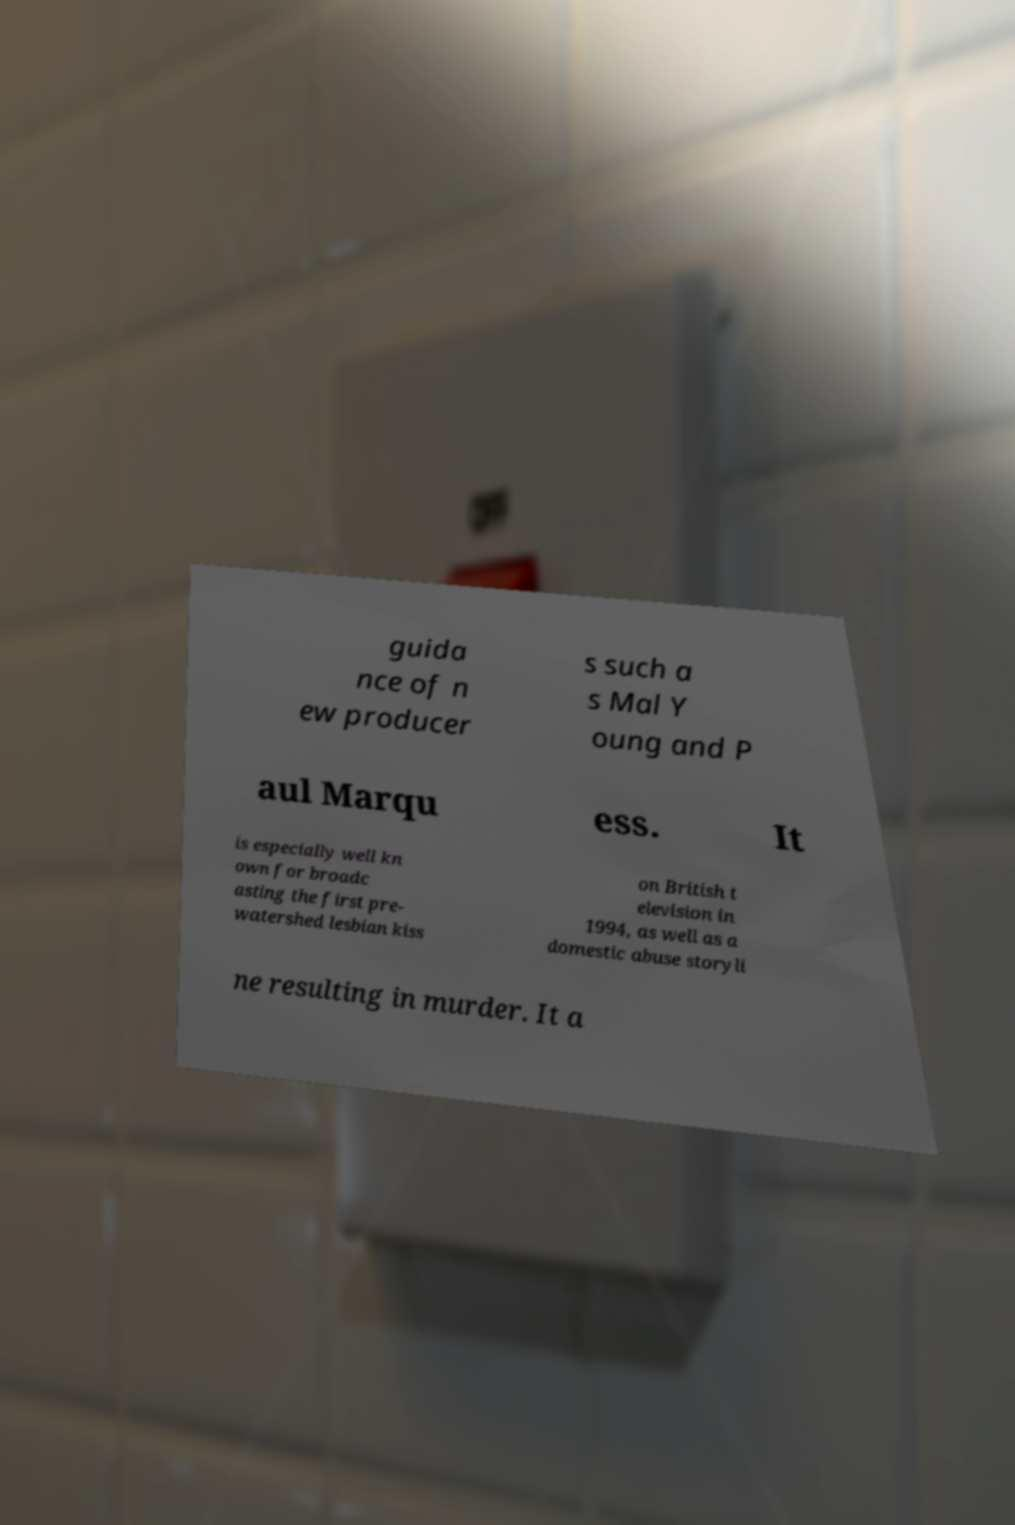I need the written content from this picture converted into text. Can you do that? guida nce of n ew producer s such a s Mal Y oung and P aul Marqu ess. It is especially well kn own for broadc asting the first pre- watershed lesbian kiss on British t elevision in 1994, as well as a domestic abuse storyli ne resulting in murder. It a 